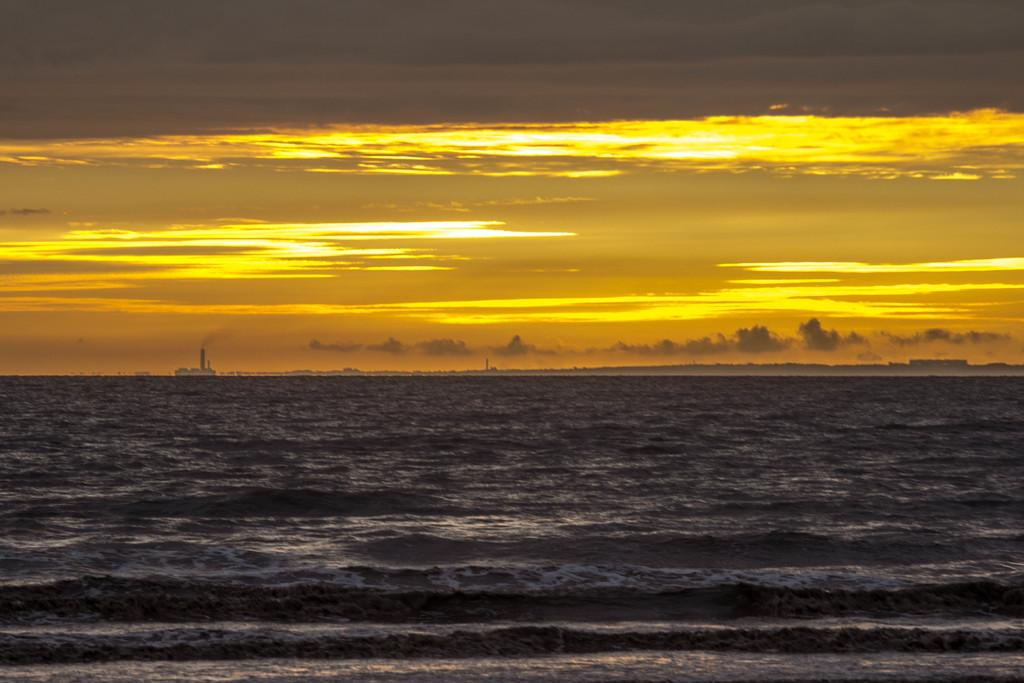What type of body of water is visible in the image? There is a sea in the image. What is floating on the water in the image? There is a ship in the water. How would you describe the color of the sky in the image? The sky has a yellow and reddish color. Are there any weather phenomena visible in the sky? Clouds are present in the sky. Where is the mask located in the image? There is no mask present in the image. What type of thread is being used to sew the calendar in the image? There is no thread or calendar present in the image. 